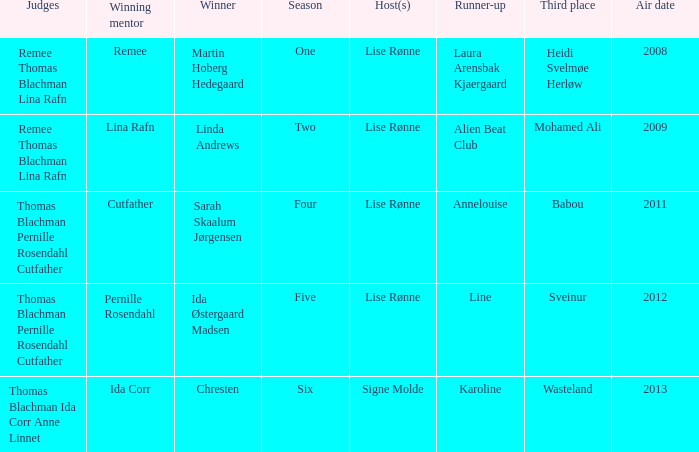Who won third place in season four? Babou. 